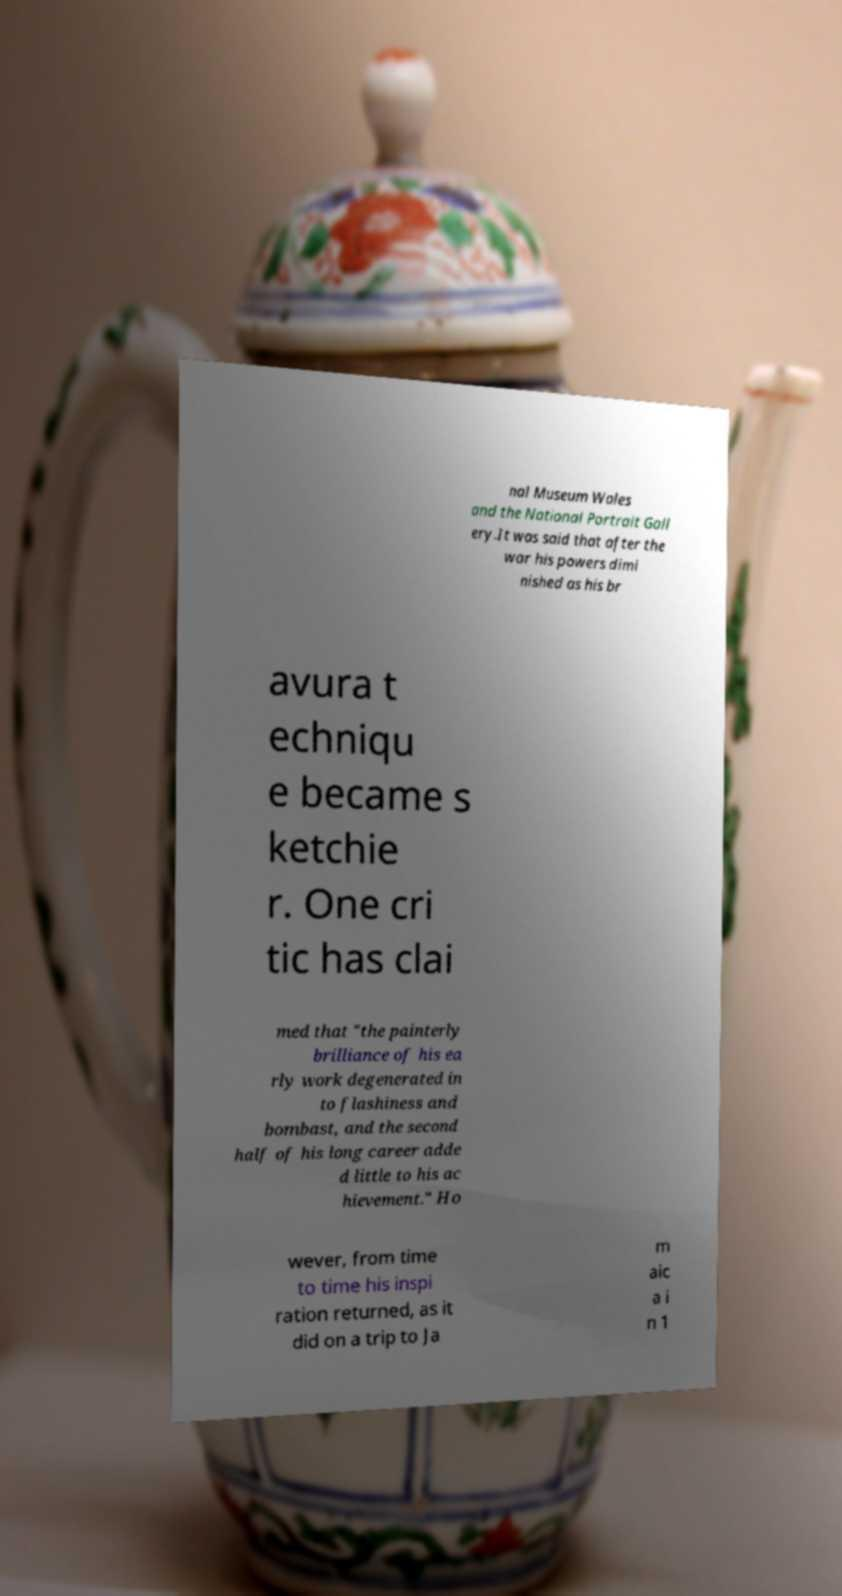Please identify and transcribe the text found in this image. nal Museum Wales and the National Portrait Gall ery.It was said that after the war his powers dimi nished as his br avura t echniqu e became s ketchie r. One cri tic has clai med that "the painterly brilliance of his ea rly work degenerated in to flashiness and bombast, and the second half of his long career adde d little to his ac hievement." Ho wever, from time to time his inspi ration returned, as it did on a trip to Ja m aic a i n 1 